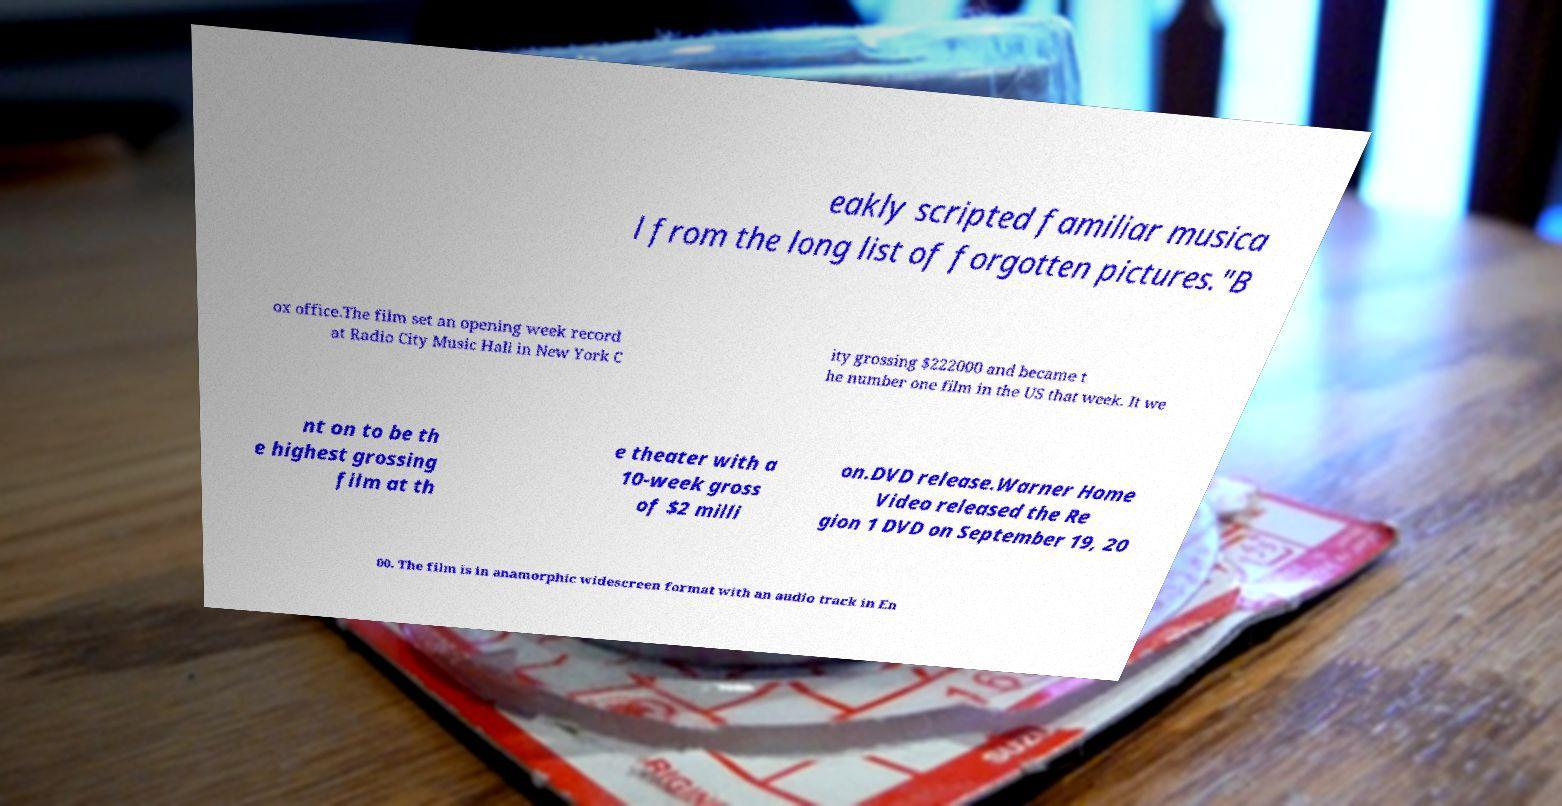For documentation purposes, I need the text within this image transcribed. Could you provide that? eakly scripted familiar musica l from the long list of forgotten pictures."B ox office.The film set an opening week record at Radio City Music Hall in New York C ity grossing $222000 and became t he number one film in the US that week. It we nt on to be th e highest grossing film at th e theater with a 10-week gross of $2 milli on.DVD release.Warner Home Video released the Re gion 1 DVD on September 19, 20 00. The film is in anamorphic widescreen format with an audio track in En 